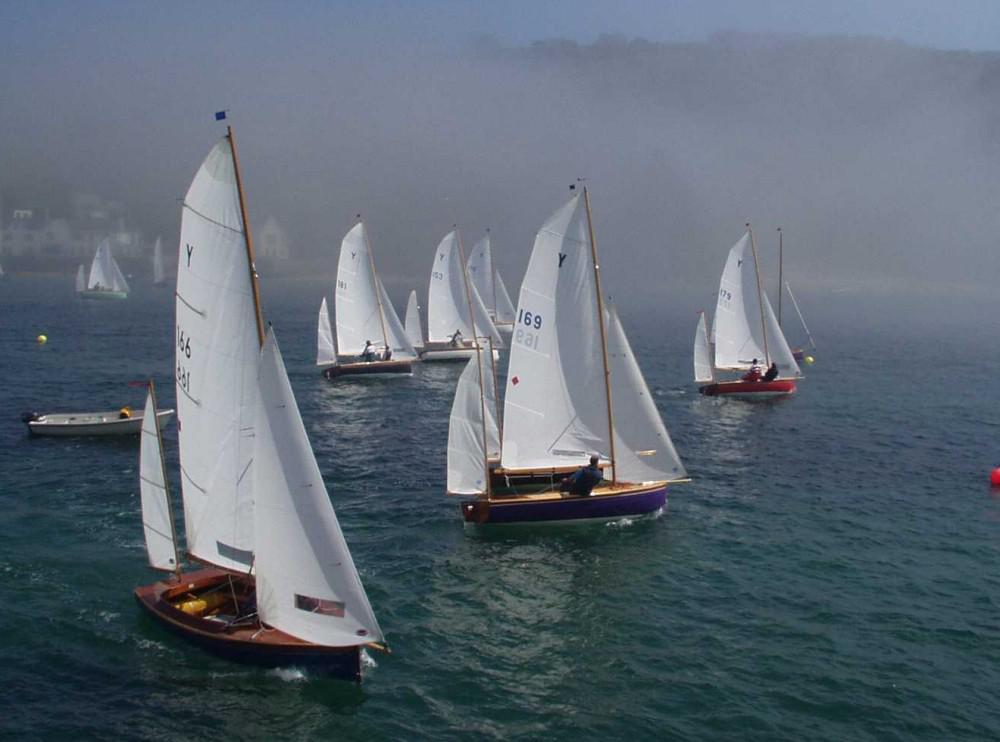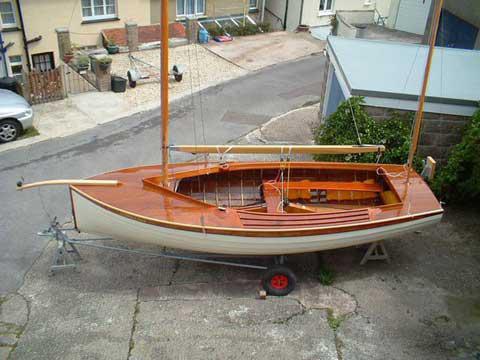The first image is the image on the left, the second image is the image on the right. For the images displayed, is the sentence "in at least one image there is a single boat with 3 raised sails" factually correct? Answer yes or no. No. The first image is the image on the left, the second image is the image on the right. Considering the images on both sides, is "There are at least five boats visible." valid? Answer yes or no. Yes. 